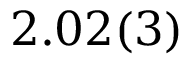<formula> <loc_0><loc_0><loc_500><loc_500>2 . 0 2 ( 3 )</formula> 